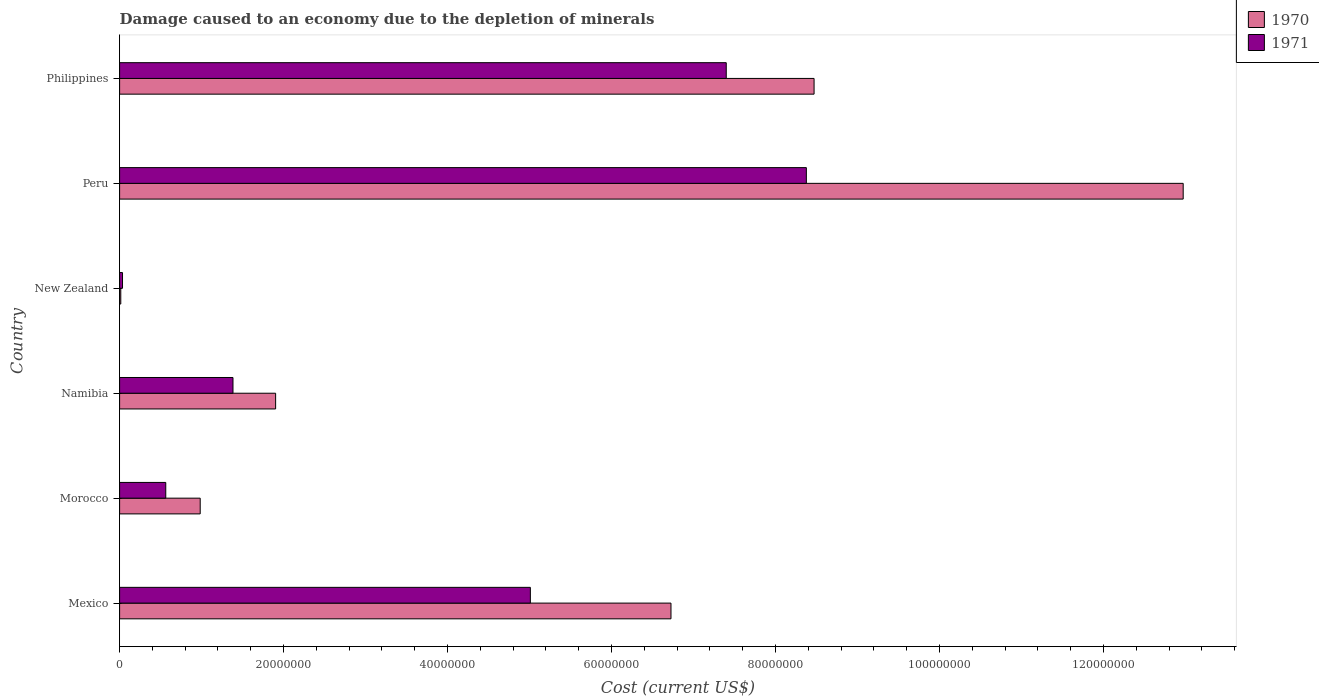How many groups of bars are there?
Provide a short and direct response. 6. Are the number of bars on each tick of the Y-axis equal?
Provide a short and direct response. Yes. How many bars are there on the 3rd tick from the top?
Give a very brief answer. 2. How many bars are there on the 1st tick from the bottom?
Provide a succinct answer. 2. What is the label of the 3rd group of bars from the top?
Give a very brief answer. New Zealand. What is the cost of damage caused due to the depletion of minerals in 1970 in Morocco?
Your response must be concise. 9.83e+06. Across all countries, what is the maximum cost of damage caused due to the depletion of minerals in 1971?
Your answer should be very brief. 8.38e+07. Across all countries, what is the minimum cost of damage caused due to the depletion of minerals in 1970?
Your answer should be very brief. 1.43e+05. In which country was the cost of damage caused due to the depletion of minerals in 1971 minimum?
Keep it short and to the point. New Zealand. What is the total cost of damage caused due to the depletion of minerals in 1970 in the graph?
Offer a very short reply. 3.11e+08. What is the difference between the cost of damage caused due to the depletion of minerals in 1971 in New Zealand and that in Peru?
Ensure brevity in your answer.  -8.34e+07. What is the difference between the cost of damage caused due to the depletion of minerals in 1971 in Mexico and the cost of damage caused due to the depletion of minerals in 1970 in Morocco?
Provide a short and direct response. 4.03e+07. What is the average cost of damage caused due to the depletion of minerals in 1971 per country?
Provide a short and direct response. 3.79e+07. What is the difference between the cost of damage caused due to the depletion of minerals in 1970 and cost of damage caused due to the depletion of minerals in 1971 in Mexico?
Offer a very short reply. 1.72e+07. What is the ratio of the cost of damage caused due to the depletion of minerals in 1971 in Mexico to that in New Zealand?
Offer a terse response. 141.19. What is the difference between the highest and the second highest cost of damage caused due to the depletion of minerals in 1971?
Ensure brevity in your answer.  9.77e+06. What is the difference between the highest and the lowest cost of damage caused due to the depletion of minerals in 1971?
Your answer should be very brief. 8.34e+07. What does the 1st bar from the top in Peru represents?
Keep it short and to the point. 1971. What does the 2nd bar from the bottom in New Zealand represents?
Give a very brief answer. 1971. Are all the bars in the graph horizontal?
Give a very brief answer. Yes. How many countries are there in the graph?
Make the answer very short. 6. What is the difference between two consecutive major ticks on the X-axis?
Your answer should be compact. 2.00e+07. Are the values on the major ticks of X-axis written in scientific E-notation?
Offer a very short reply. No. Does the graph contain grids?
Your response must be concise. No. Where does the legend appear in the graph?
Your response must be concise. Top right. What is the title of the graph?
Ensure brevity in your answer.  Damage caused to an economy due to the depletion of minerals. What is the label or title of the X-axis?
Keep it short and to the point. Cost (current US$). What is the label or title of the Y-axis?
Provide a short and direct response. Country. What is the Cost (current US$) in 1970 in Mexico?
Offer a terse response. 6.73e+07. What is the Cost (current US$) of 1971 in Mexico?
Make the answer very short. 5.01e+07. What is the Cost (current US$) of 1970 in Morocco?
Offer a terse response. 9.83e+06. What is the Cost (current US$) of 1971 in Morocco?
Give a very brief answer. 5.63e+06. What is the Cost (current US$) of 1970 in Namibia?
Make the answer very short. 1.90e+07. What is the Cost (current US$) in 1971 in Namibia?
Give a very brief answer. 1.38e+07. What is the Cost (current US$) in 1970 in New Zealand?
Ensure brevity in your answer.  1.43e+05. What is the Cost (current US$) of 1971 in New Zealand?
Give a very brief answer. 3.55e+05. What is the Cost (current US$) of 1970 in Peru?
Ensure brevity in your answer.  1.30e+08. What is the Cost (current US$) in 1971 in Peru?
Keep it short and to the point. 8.38e+07. What is the Cost (current US$) of 1970 in Philippines?
Provide a succinct answer. 8.47e+07. What is the Cost (current US$) of 1971 in Philippines?
Your answer should be very brief. 7.40e+07. Across all countries, what is the maximum Cost (current US$) in 1970?
Provide a succinct answer. 1.30e+08. Across all countries, what is the maximum Cost (current US$) in 1971?
Your response must be concise. 8.38e+07. Across all countries, what is the minimum Cost (current US$) of 1970?
Provide a short and direct response. 1.43e+05. Across all countries, what is the minimum Cost (current US$) of 1971?
Your answer should be very brief. 3.55e+05. What is the total Cost (current US$) of 1970 in the graph?
Offer a terse response. 3.11e+08. What is the total Cost (current US$) in 1971 in the graph?
Offer a terse response. 2.28e+08. What is the difference between the Cost (current US$) in 1970 in Mexico and that in Morocco?
Provide a succinct answer. 5.74e+07. What is the difference between the Cost (current US$) in 1971 in Mexico and that in Morocco?
Keep it short and to the point. 4.45e+07. What is the difference between the Cost (current US$) of 1970 in Mexico and that in Namibia?
Make the answer very short. 4.82e+07. What is the difference between the Cost (current US$) in 1971 in Mexico and that in Namibia?
Your response must be concise. 3.63e+07. What is the difference between the Cost (current US$) in 1970 in Mexico and that in New Zealand?
Offer a very short reply. 6.71e+07. What is the difference between the Cost (current US$) of 1971 in Mexico and that in New Zealand?
Provide a short and direct response. 4.97e+07. What is the difference between the Cost (current US$) in 1970 in Mexico and that in Peru?
Your answer should be very brief. -6.25e+07. What is the difference between the Cost (current US$) of 1971 in Mexico and that in Peru?
Keep it short and to the point. -3.37e+07. What is the difference between the Cost (current US$) in 1970 in Mexico and that in Philippines?
Provide a short and direct response. -1.75e+07. What is the difference between the Cost (current US$) in 1971 in Mexico and that in Philippines?
Your answer should be compact. -2.39e+07. What is the difference between the Cost (current US$) in 1970 in Morocco and that in Namibia?
Your response must be concise. -9.20e+06. What is the difference between the Cost (current US$) of 1971 in Morocco and that in Namibia?
Your answer should be compact. -8.20e+06. What is the difference between the Cost (current US$) in 1970 in Morocco and that in New Zealand?
Give a very brief answer. 9.69e+06. What is the difference between the Cost (current US$) of 1971 in Morocco and that in New Zealand?
Make the answer very short. 5.28e+06. What is the difference between the Cost (current US$) in 1970 in Morocco and that in Peru?
Your answer should be compact. -1.20e+08. What is the difference between the Cost (current US$) in 1971 in Morocco and that in Peru?
Give a very brief answer. -7.81e+07. What is the difference between the Cost (current US$) of 1970 in Morocco and that in Philippines?
Offer a terse response. -7.49e+07. What is the difference between the Cost (current US$) of 1971 in Morocco and that in Philippines?
Provide a short and direct response. -6.84e+07. What is the difference between the Cost (current US$) in 1970 in Namibia and that in New Zealand?
Your answer should be compact. 1.89e+07. What is the difference between the Cost (current US$) in 1971 in Namibia and that in New Zealand?
Your answer should be compact. 1.35e+07. What is the difference between the Cost (current US$) in 1970 in Namibia and that in Peru?
Give a very brief answer. -1.11e+08. What is the difference between the Cost (current US$) of 1971 in Namibia and that in Peru?
Keep it short and to the point. -6.99e+07. What is the difference between the Cost (current US$) of 1970 in Namibia and that in Philippines?
Make the answer very short. -6.57e+07. What is the difference between the Cost (current US$) in 1971 in Namibia and that in Philippines?
Give a very brief answer. -6.02e+07. What is the difference between the Cost (current US$) of 1970 in New Zealand and that in Peru?
Your response must be concise. -1.30e+08. What is the difference between the Cost (current US$) in 1971 in New Zealand and that in Peru?
Provide a short and direct response. -8.34e+07. What is the difference between the Cost (current US$) in 1970 in New Zealand and that in Philippines?
Your response must be concise. -8.46e+07. What is the difference between the Cost (current US$) of 1971 in New Zealand and that in Philippines?
Keep it short and to the point. -7.36e+07. What is the difference between the Cost (current US$) of 1970 in Peru and that in Philippines?
Your answer should be very brief. 4.50e+07. What is the difference between the Cost (current US$) of 1971 in Peru and that in Philippines?
Your response must be concise. 9.77e+06. What is the difference between the Cost (current US$) in 1970 in Mexico and the Cost (current US$) in 1971 in Morocco?
Make the answer very short. 6.16e+07. What is the difference between the Cost (current US$) of 1970 in Mexico and the Cost (current US$) of 1971 in Namibia?
Provide a short and direct response. 5.34e+07. What is the difference between the Cost (current US$) in 1970 in Mexico and the Cost (current US$) in 1971 in New Zealand?
Offer a terse response. 6.69e+07. What is the difference between the Cost (current US$) of 1970 in Mexico and the Cost (current US$) of 1971 in Peru?
Offer a very short reply. -1.65e+07. What is the difference between the Cost (current US$) in 1970 in Mexico and the Cost (current US$) in 1971 in Philippines?
Your response must be concise. -6.74e+06. What is the difference between the Cost (current US$) of 1970 in Morocco and the Cost (current US$) of 1971 in Namibia?
Provide a succinct answer. -4.00e+06. What is the difference between the Cost (current US$) of 1970 in Morocco and the Cost (current US$) of 1971 in New Zealand?
Provide a short and direct response. 9.48e+06. What is the difference between the Cost (current US$) in 1970 in Morocco and the Cost (current US$) in 1971 in Peru?
Provide a succinct answer. -7.39e+07. What is the difference between the Cost (current US$) in 1970 in Morocco and the Cost (current US$) in 1971 in Philippines?
Your answer should be very brief. -6.42e+07. What is the difference between the Cost (current US$) of 1970 in Namibia and the Cost (current US$) of 1971 in New Zealand?
Make the answer very short. 1.87e+07. What is the difference between the Cost (current US$) of 1970 in Namibia and the Cost (current US$) of 1971 in Peru?
Offer a terse response. -6.47e+07. What is the difference between the Cost (current US$) in 1970 in Namibia and the Cost (current US$) in 1971 in Philippines?
Provide a short and direct response. -5.50e+07. What is the difference between the Cost (current US$) in 1970 in New Zealand and the Cost (current US$) in 1971 in Peru?
Provide a succinct answer. -8.36e+07. What is the difference between the Cost (current US$) of 1970 in New Zealand and the Cost (current US$) of 1971 in Philippines?
Give a very brief answer. -7.39e+07. What is the difference between the Cost (current US$) in 1970 in Peru and the Cost (current US$) in 1971 in Philippines?
Provide a succinct answer. 5.57e+07. What is the average Cost (current US$) in 1970 per country?
Your answer should be very brief. 5.18e+07. What is the average Cost (current US$) in 1971 per country?
Keep it short and to the point. 3.79e+07. What is the difference between the Cost (current US$) of 1970 and Cost (current US$) of 1971 in Mexico?
Provide a short and direct response. 1.72e+07. What is the difference between the Cost (current US$) of 1970 and Cost (current US$) of 1971 in Morocco?
Keep it short and to the point. 4.20e+06. What is the difference between the Cost (current US$) in 1970 and Cost (current US$) in 1971 in Namibia?
Offer a terse response. 5.20e+06. What is the difference between the Cost (current US$) of 1970 and Cost (current US$) of 1971 in New Zealand?
Give a very brief answer. -2.11e+05. What is the difference between the Cost (current US$) in 1970 and Cost (current US$) in 1971 in Peru?
Provide a short and direct response. 4.60e+07. What is the difference between the Cost (current US$) in 1970 and Cost (current US$) in 1971 in Philippines?
Keep it short and to the point. 1.07e+07. What is the ratio of the Cost (current US$) of 1970 in Mexico to that in Morocco?
Ensure brevity in your answer.  6.84. What is the ratio of the Cost (current US$) of 1971 in Mexico to that in Morocco?
Provide a succinct answer. 8.9. What is the ratio of the Cost (current US$) in 1970 in Mexico to that in Namibia?
Your answer should be compact. 3.53. What is the ratio of the Cost (current US$) of 1971 in Mexico to that in Namibia?
Ensure brevity in your answer.  3.62. What is the ratio of the Cost (current US$) of 1970 in Mexico to that in New Zealand?
Your answer should be compact. 469.14. What is the ratio of the Cost (current US$) of 1971 in Mexico to that in New Zealand?
Your answer should be compact. 141.19. What is the ratio of the Cost (current US$) in 1970 in Mexico to that in Peru?
Give a very brief answer. 0.52. What is the ratio of the Cost (current US$) of 1971 in Mexico to that in Peru?
Provide a succinct answer. 0.6. What is the ratio of the Cost (current US$) of 1970 in Mexico to that in Philippines?
Keep it short and to the point. 0.79. What is the ratio of the Cost (current US$) in 1971 in Mexico to that in Philippines?
Your answer should be very brief. 0.68. What is the ratio of the Cost (current US$) of 1970 in Morocco to that in Namibia?
Make the answer very short. 0.52. What is the ratio of the Cost (current US$) in 1971 in Morocco to that in Namibia?
Make the answer very short. 0.41. What is the ratio of the Cost (current US$) of 1970 in Morocco to that in New Zealand?
Give a very brief answer. 68.59. What is the ratio of the Cost (current US$) of 1971 in Morocco to that in New Zealand?
Make the answer very short. 15.87. What is the ratio of the Cost (current US$) of 1970 in Morocco to that in Peru?
Ensure brevity in your answer.  0.08. What is the ratio of the Cost (current US$) of 1971 in Morocco to that in Peru?
Your response must be concise. 0.07. What is the ratio of the Cost (current US$) in 1970 in Morocco to that in Philippines?
Give a very brief answer. 0.12. What is the ratio of the Cost (current US$) of 1971 in Morocco to that in Philippines?
Your response must be concise. 0.08. What is the ratio of the Cost (current US$) in 1970 in Namibia to that in New Zealand?
Provide a short and direct response. 132.75. What is the ratio of the Cost (current US$) in 1971 in Namibia to that in New Zealand?
Your answer should be very brief. 38.97. What is the ratio of the Cost (current US$) of 1970 in Namibia to that in Peru?
Your answer should be compact. 0.15. What is the ratio of the Cost (current US$) in 1971 in Namibia to that in Peru?
Give a very brief answer. 0.17. What is the ratio of the Cost (current US$) of 1970 in Namibia to that in Philippines?
Your answer should be very brief. 0.22. What is the ratio of the Cost (current US$) of 1971 in Namibia to that in Philippines?
Offer a very short reply. 0.19. What is the ratio of the Cost (current US$) in 1970 in New Zealand to that in Peru?
Your answer should be very brief. 0. What is the ratio of the Cost (current US$) of 1971 in New Zealand to that in Peru?
Make the answer very short. 0. What is the ratio of the Cost (current US$) of 1970 in New Zealand to that in Philippines?
Your answer should be very brief. 0. What is the ratio of the Cost (current US$) in 1971 in New Zealand to that in Philippines?
Keep it short and to the point. 0. What is the ratio of the Cost (current US$) in 1970 in Peru to that in Philippines?
Ensure brevity in your answer.  1.53. What is the ratio of the Cost (current US$) of 1971 in Peru to that in Philippines?
Ensure brevity in your answer.  1.13. What is the difference between the highest and the second highest Cost (current US$) of 1970?
Keep it short and to the point. 4.50e+07. What is the difference between the highest and the second highest Cost (current US$) in 1971?
Offer a very short reply. 9.77e+06. What is the difference between the highest and the lowest Cost (current US$) of 1970?
Make the answer very short. 1.30e+08. What is the difference between the highest and the lowest Cost (current US$) of 1971?
Your answer should be compact. 8.34e+07. 